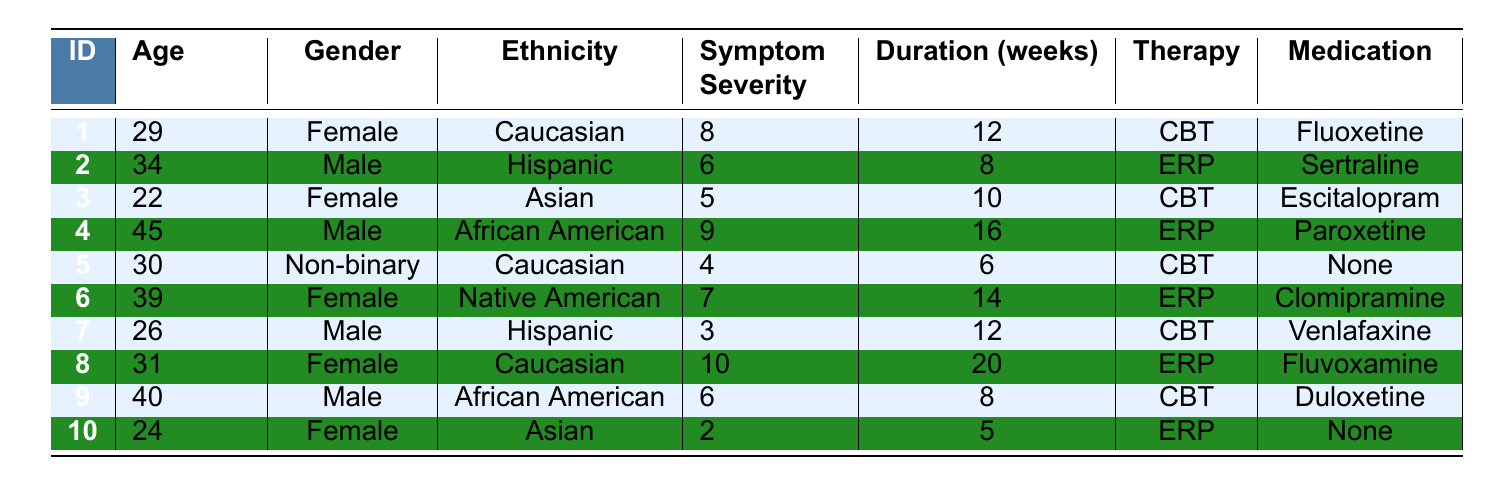What is the symptom severity of patient ID 4? The table lists patient ID 4 with a symptom severity score of 9.
Answer: 9 How many weeks did patient ID 5 undergo treatment? According to the table, patient ID 5's treatment duration is recorded as 6 weeks.
Answer: 6 Which therapy did the youngest patient receive? The youngest patient is patient ID 3, who is 22 years old and received CBT therapy.
Answer: CBT Is there a patient with symptom severity of 10? Yes, patient ID 8 has a symptom severity score of 10.
Answer: Yes What is the average symptom severity for all patients? The total symptom severity scores are (8 + 6 + 5 + 9 + 4 + 7 + 3 + 10 + 6 + 2) = 60. There are 10 patients, so the average is 60/10 = 6.
Answer: 6 How many patients were treated with ERP? Looking at the table, patients ID 2, 4, 6, and 8 were treated with ERP, totaling 4 patients.
Answer: 4 What is the gender of the patient with the highest symptom severity? Patient ID 8, who has the highest symptom severity of 10, is female.
Answer: Female How does the average treatment duration of male patients compare to female patients? Male patients' treatment durations are 8, 16, 12, and 8 weeks (average = 11 weeks). Female patients' durations are 12, 10, 14, and 20 weeks (average = 14 weeks). Male average is less than female average.
Answer: Male average is less than female average Which medication is associated with the oldest patient? The oldest patient is ID 9 who is 40 years old; their associated medication is Duloxetine.
Answer: Duloxetine Is there a patient receiving CBT who did not take any medication? Yes, patient ID 5 received CBT therapy and did not take any medication.
Answer: Yes 